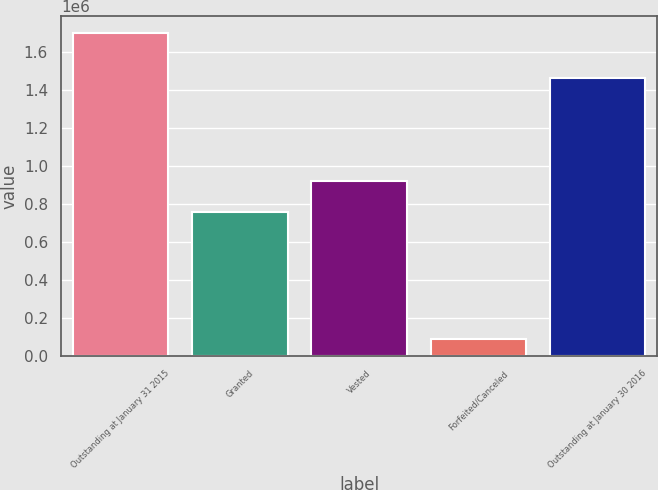<chart> <loc_0><loc_0><loc_500><loc_500><bar_chart><fcel>Outstanding at January 31 2015<fcel>Granted<fcel>Vested<fcel>Forfeited/Canceled<fcel>Outstanding at January 30 2016<nl><fcel>1.704e+06<fcel>758000<fcel>919800<fcel>86000<fcel>1.462e+06<nl></chart> 